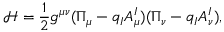<formula> <loc_0><loc_0><loc_500><loc_500>\mathcal { H } = \frac { 1 } { 2 } g ^ { \mu \nu } ( \Pi _ { \mu } - q _ { I } A _ { \mu } ^ { I } ) ( \Pi _ { \nu } - q _ { I } A _ { \nu } ^ { I } ) ,</formula> 